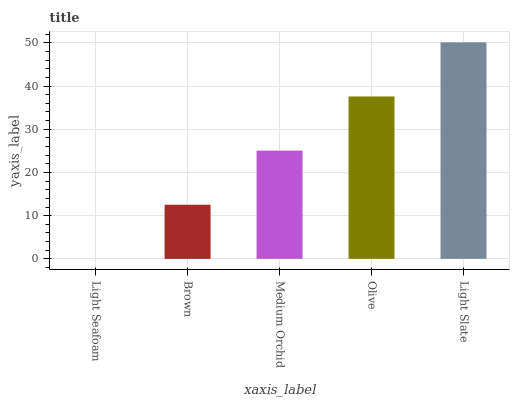Is Light Seafoam the minimum?
Answer yes or no. Yes. Is Light Slate the maximum?
Answer yes or no. Yes. Is Brown the minimum?
Answer yes or no. No. Is Brown the maximum?
Answer yes or no. No. Is Brown greater than Light Seafoam?
Answer yes or no. Yes. Is Light Seafoam less than Brown?
Answer yes or no. Yes. Is Light Seafoam greater than Brown?
Answer yes or no. No. Is Brown less than Light Seafoam?
Answer yes or no. No. Is Medium Orchid the high median?
Answer yes or no. Yes. Is Medium Orchid the low median?
Answer yes or no. Yes. Is Olive the high median?
Answer yes or no. No. Is Olive the low median?
Answer yes or no. No. 